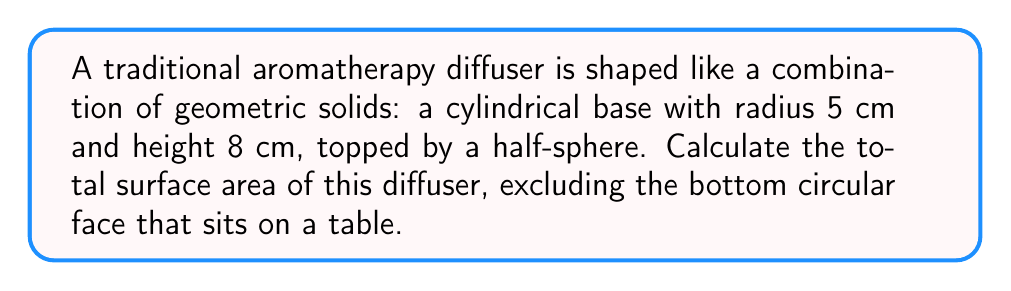Show me your answer to this math problem. Let's approach this step-by-step:

1) The diffuser consists of two parts: a cylinder and a half-sphere.

2) For the cylindrical part:
   - Lateral surface area of cylinder = $2\pi rh$
   where $r$ is the radius and $h$ is the height
   - $A_{cylinder} = 2\pi(5)(8) = 80\pi$ cm²

3) For the half-sphere part:
   - Surface area of a sphere = $4\pi r^2$
   - Surface area of a half-sphere = $\frac{1}{2}(4\pi r^2) = 2\pi r^2$
   - $A_{half-sphere} = 2\pi(5^2) = 50\pi$ cm²

4) The top circular face of the cylinder is replaced by the half-sphere, so we don't need to calculate it separately.

5) Total surface area:
   $A_{total} = A_{cylinder} + A_{half-sphere}$
   $A_{total} = 80\pi + 50\pi = 130\pi$ cm²

[asy]
import geometry;

size(200);

// Draw cylinder
path p = (5,0)--(5,8)--(0,8)--(0,0);
draw(p);
draw(shift(0,8)*scale(5,1)*unitcircle);

// Draw half-sphere
draw(shift(0,8)*scale(5,5)*arc((0,0), 1, 180, 360));

// Labels
label("5 cm", (2.5,0), S);
label("8 cm", (5,4), E);
</asy]
Answer: $130\pi$ cm² 